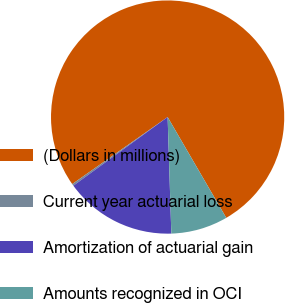Convert chart. <chart><loc_0><loc_0><loc_500><loc_500><pie_chart><fcel>(Dollars in millions)<fcel>Current year actuarial loss<fcel>Amortization of actuarial gain<fcel>Amounts recognized in OCI<nl><fcel>76.37%<fcel>0.27%<fcel>15.49%<fcel>7.88%<nl></chart> 